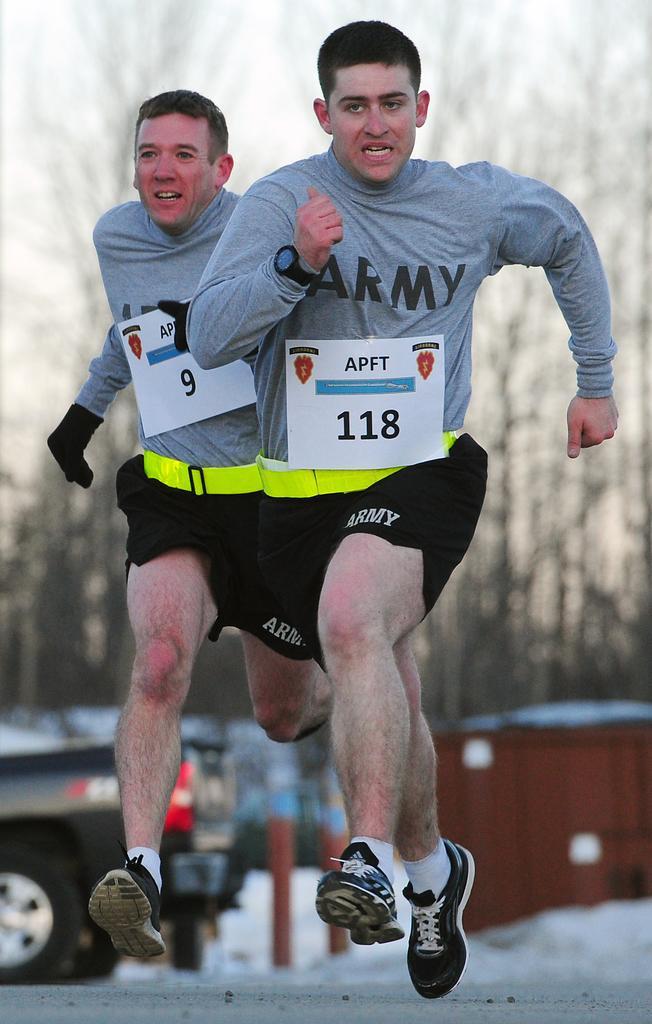Please provide a concise description of this image. In this image I can see two men wearing t-shirts, shorts, shoes and running on the road. In the background, I can see a vehicle on the road, a house and trees. At the top I can see the sky. 